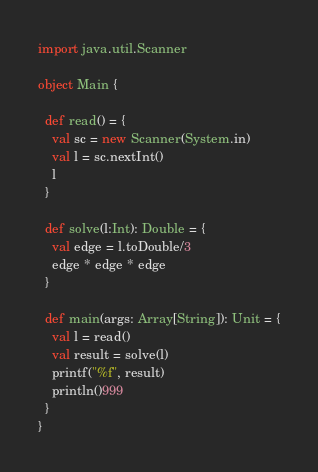Convert code to text. <code><loc_0><loc_0><loc_500><loc_500><_Scala_>import java.util.Scanner

object Main {

  def read() = {
    val sc = new Scanner(System.in)
    val l = sc.nextInt()
    l
  }

  def solve(l:Int): Double = {
    val edge = l.toDouble/3
    edge * edge * edge
  }

  def main(args: Array[String]): Unit = {
    val l = read()
    val result = solve(l)
    printf("%f", result)
    println()999
  }
}</code> 